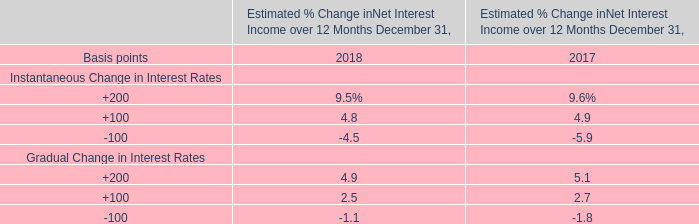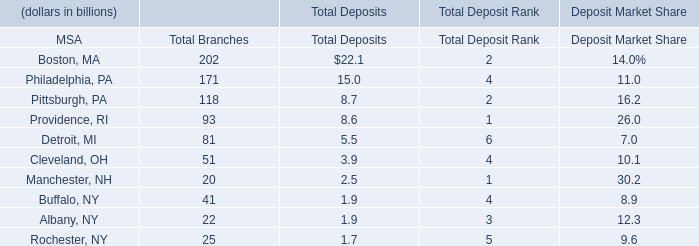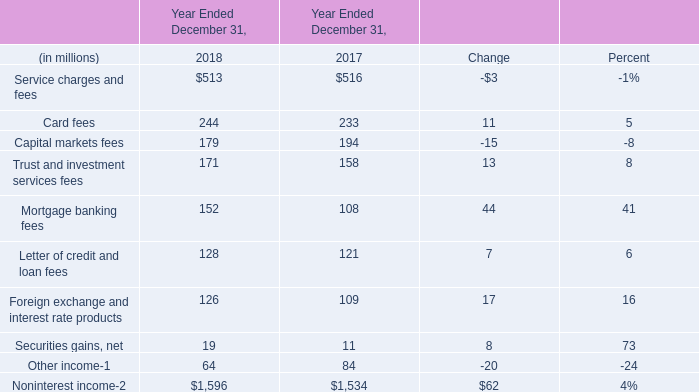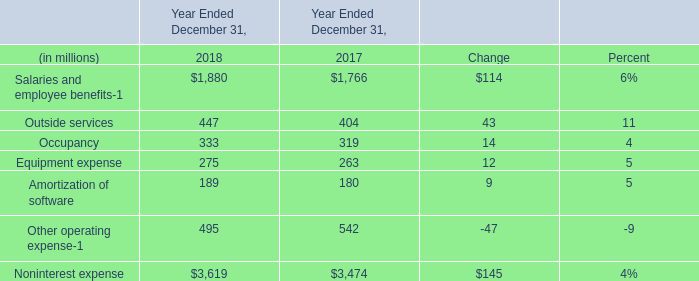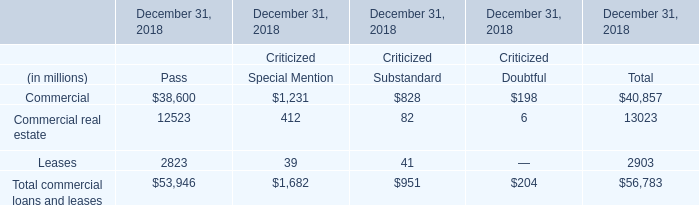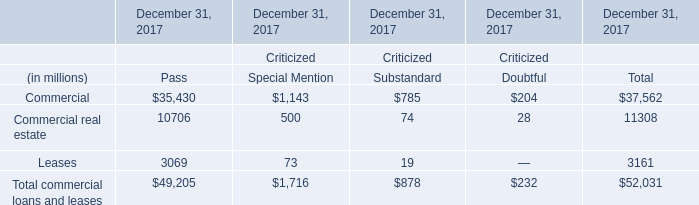What's the greatest value of Noninterest income in 2018? (in million) 
Answer: 513. 